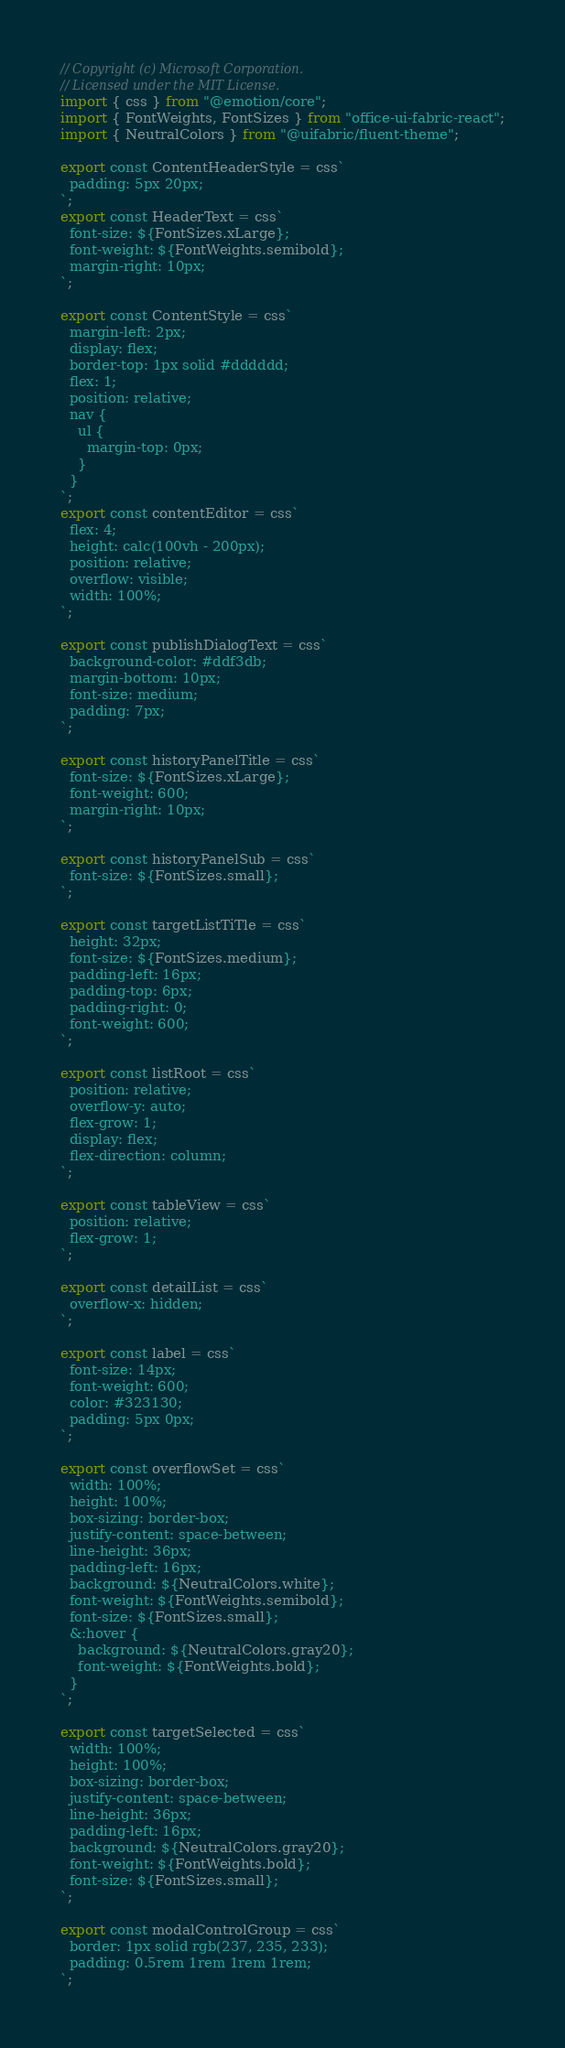<code> <loc_0><loc_0><loc_500><loc_500><_TypeScript_>// Copyright (c) Microsoft Corporation.
// Licensed under the MIT License.
import { css } from "@emotion/core";
import { FontWeights, FontSizes } from "office-ui-fabric-react";
import { NeutralColors } from "@uifabric/fluent-theme";

export const ContentHeaderStyle = css`
  padding: 5px 20px;
`;
export const HeaderText = css`
  font-size: ${FontSizes.xLarge};
  font-weight: ${FontWeights.semibold};
  margin-right: 10px;
`;

export const ContentStyle = css`
  margin-left: 2px;
  display: flex;
  border-top: 1px solid #dddddd;
  flex: 1;
  position: relative;
  nav {
    ul {
      margin-top: 0px;
    }
  }
`;
export const contentEditor = css`
  flex: 4;
  height: calc(100vh - 200px);
  position: relative;
  overflow: visible;
  width: 100%;
`;

export const publishDialogText = css`
  background-color: #ddf3db;
  margin-bottom: 10px;
  font-size: medium;
  padding: 7px;
`;

export const historyPanelTitle = css`
  font-size: ${FontSizes.xLarge};
  font-weight: 600;
  margin-right: 10px;
`;

export const historyPanelSub = css`
  font-size: ${FontSizes.small};
`;

export const targetListTiTle = css`
  height: 32px;
  font-size: ${FontSizes.medium};
  padding-left: 16px;
  padding-top: 6px;
  padding-right: 0;
  font-weight: 600;
`;

export const listRoot = css`
  position: relative;
  overflow-y: auto;
  flex-grow: 1;
  display: flex;
  flex-direction: column;
`;

export const tableView = css`
  position: relative;
  flex-grow: 1;
`;

export const detailList = css`
  overflow-x: hidden;
`;

export const label = css`
  font-size: 14px;
  font-weight: 600;
  color: #323130;
  padding: 5px 0px;
`;

export const overflowSet = css`
  width: 100%;
  height: 100%;
  box-sizing: border-box;
  justify-content: space-between;
  line-height: 36px;
  padding-left: 16px;
  background: ${NeutralColors.white};
  font-weight: ${FontWeights.semibold};
  font-size: ${FontSizes.small};
  &:hover {
    background: ${NeutralColors.gray20};
    font-weight: ${FontWeights.bold};
  }
`;

export const targetSelected = css`
  width: 100%;
  height: 100%;
  box-sizing: border-box;
  justify-content: space-between;
  line-height: 36px;
  padding-left: 16px;
  background: ${NeutralColors.gray20};
  font-weight: ${FontWeights.bold};
  font-size: ${FontSizes.small};
`;

export const modalControlGroup = css`
  border: 1px solid rgb(237, 235, 233);
  padding: 0.5rem 1rem 1rem 1rem;
`;
</code> 